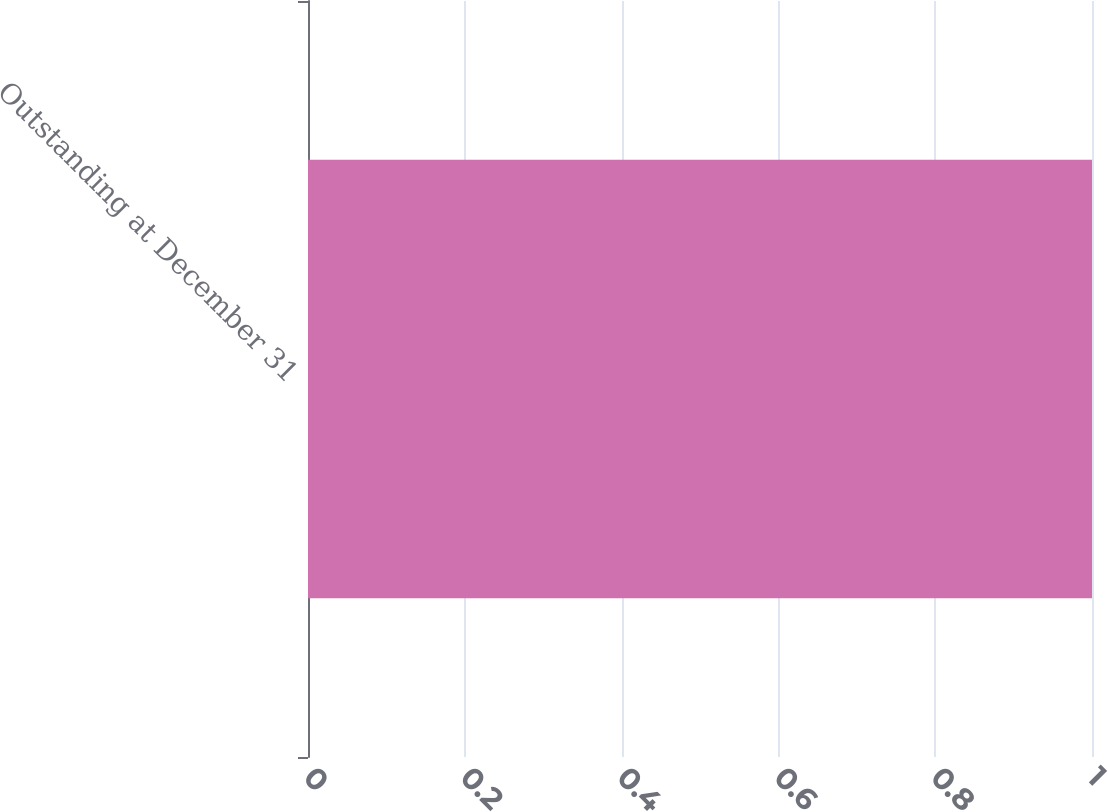Convert chart. <chart><loc_0><loc_0><loc_500><loc_500><bar_chart><fcel>Outstanding at December 31<nl><fcel>1<nl></chart> 